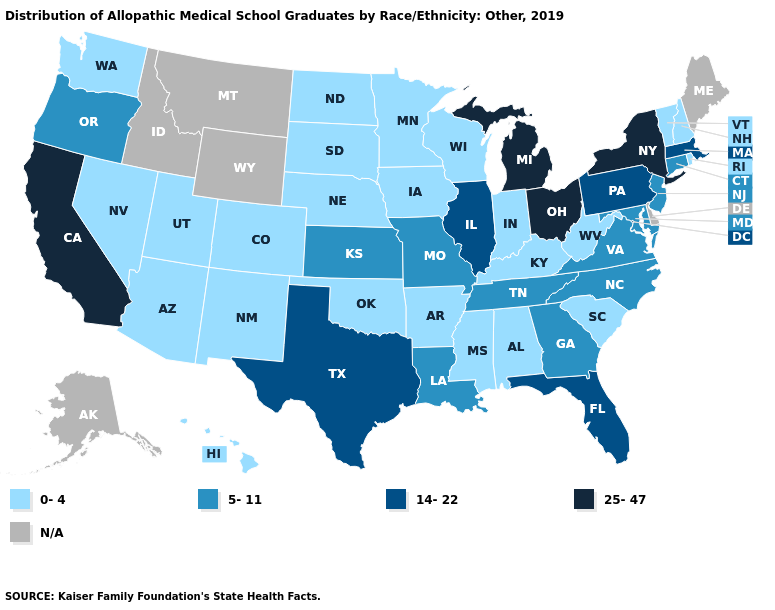Does Florida have the lowest value in the USA?
Be succinct. No. Does Nebraska have the highest value in the MidWest?
Quick response, please. No. What is the value of Rhode Island?
Short answer required. 0-4. Which states have the highest value in the USA?
Concise answer only. California, Michigan, New York, Ohio. Name the states that have a value in the range 0-4?
Keep it brief. Alabama, Arizona, Arkansas, Colorado, Hawaii, Indiana, Iowa, Kentucky, Minnesota, Mississippi, Nebraska, Nevada, New Hampshire, New Mexico, North Dakota, Oklahoma, Rhode Island, South Carolina, South Dakota, Utah, Vermont, Washington, West Virginia, Wisconsin. Which states hav the highest value in the MidWest?
Answer briefly. Michigan, Ohio. Does New Hampshire have the lowest value in the Northeast?
Concise answer only. Yes. What is the value of Mississippi?
Give a very brief answer. 0-4. Name the states that have a value in the range 25-47?
Keep it brief. California, Michigan, New York, Ohio. Among the states that border Idaho , which have the lowest value?
Quick response, please. Nevada, Utah, Washington. Does Hawaii have the highest value in the West?
Be succinct. No. Name the states that have a value in the range 0-4?
Short answer required. Alabama, Arizona, Arkansas, Colorado, Hawaii, Indiana, Iowa, Kentucky, Minnesota, Mississippi, Nebraska, Nevada, New Hampshire, New Mexico, North Dakota, Oklahoma, Rhode Island, South Carolina, South Dakota, Utah, Vermont, Washington, West Virginia, Wisconsin. What is the value of Washington?
Write a very short answer. 0-4. What is the value of Kentucky?
Quick response, please. 0-4. Name the states that have a value in the range 25-47?
Quick response, please. California, Michigan, New York, Ohio. 